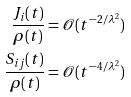<formula> <loc_0><loc_0><loc_500><loc_500>\frac { J _ { i } ( t ) } { \rho ( t ) } & = \mathcal { O } ( t ^ { - 2 / \lambda ^ { 2 } } ) \\ \frac { S _ { i j } ( t ) } { \rho ( t ) } & = \mathcal { O } ( t ^ { - 4 / \lambda ^ { 2 } } )</formula> 